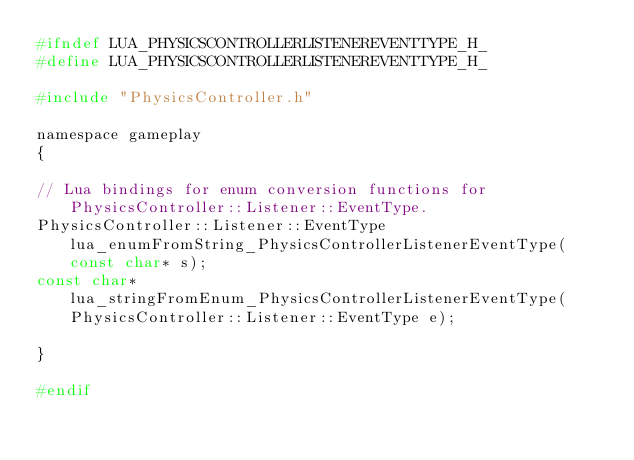<code> <loc_0><loc_0><loc_500><loc_500><_C_>#ifndef LUA_PHYSICSCONTROLLERLISTENEREVENTTYPE_H_
#define LUA_PHYSICSCONTROLLERLISTENEREVENTTYPE_H_

#include "PhysicsController.h"

namespace gameplay
{

// Lua bindings for enum conversion functions for PhysicsController::Listener::EventType.
PhysicsController::Listener::EventType lua_enumFromString_PhysicsControllerListenerEventType(const char* s);
const char* lua_stringFromEnum_PhysicsControllerListenerEventType(PhysicsController::Listener::EventType e);

}

#endif
</code> 